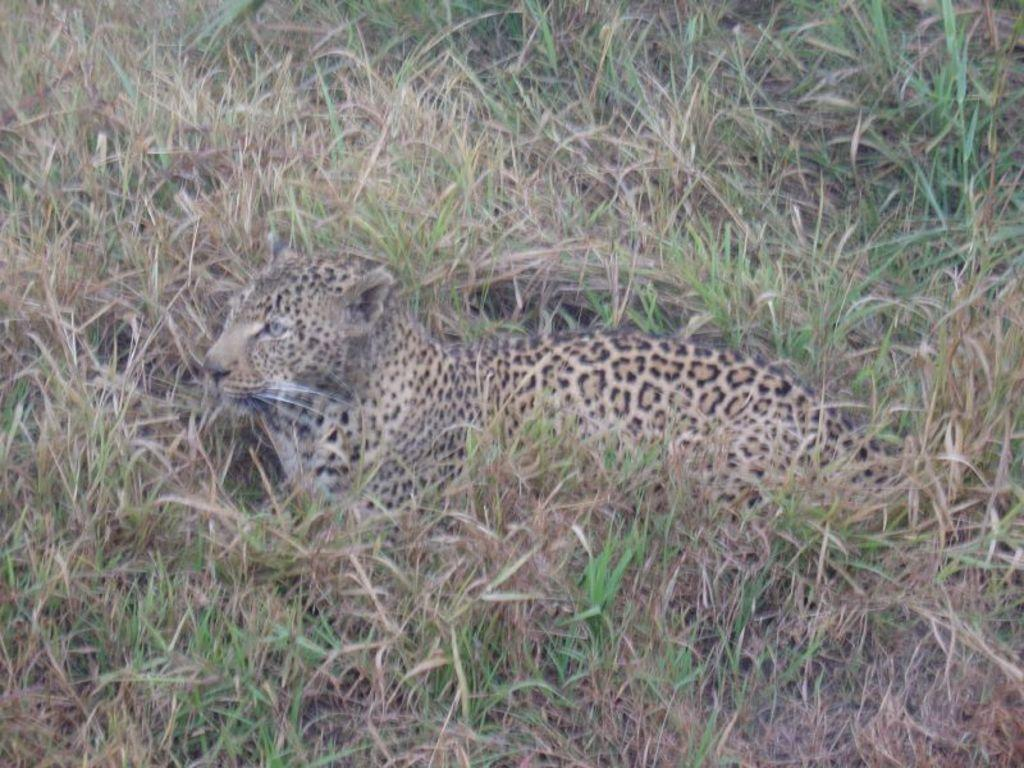Where was the image taken? The image was clicked outside the city. What is the main subject of the image? There is an animal in the center of the image. What is the animal doing in the image? The animal appears to be sitting on the ground. What type of vegetation can be seen in the image? There is grass visible in the image. What type of seat is the animal using in the image? There is no seat present in the image; the animal is sitting on the ground. What type of operation is being performed on the animal in the image? There is no operation being performed on the animal in the image; it is simply sitting on the ground. 